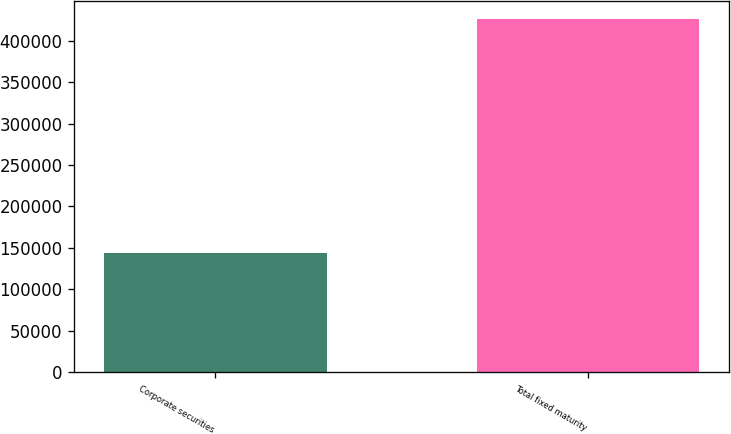Convert chart. <chart><loc_0><loc_0><loc_500><loc_500><bar_chart><fcel>Corporate securities<fcel>Total fixed maturity<nl><fcel>143889<fcel>426973<nl></chart> 